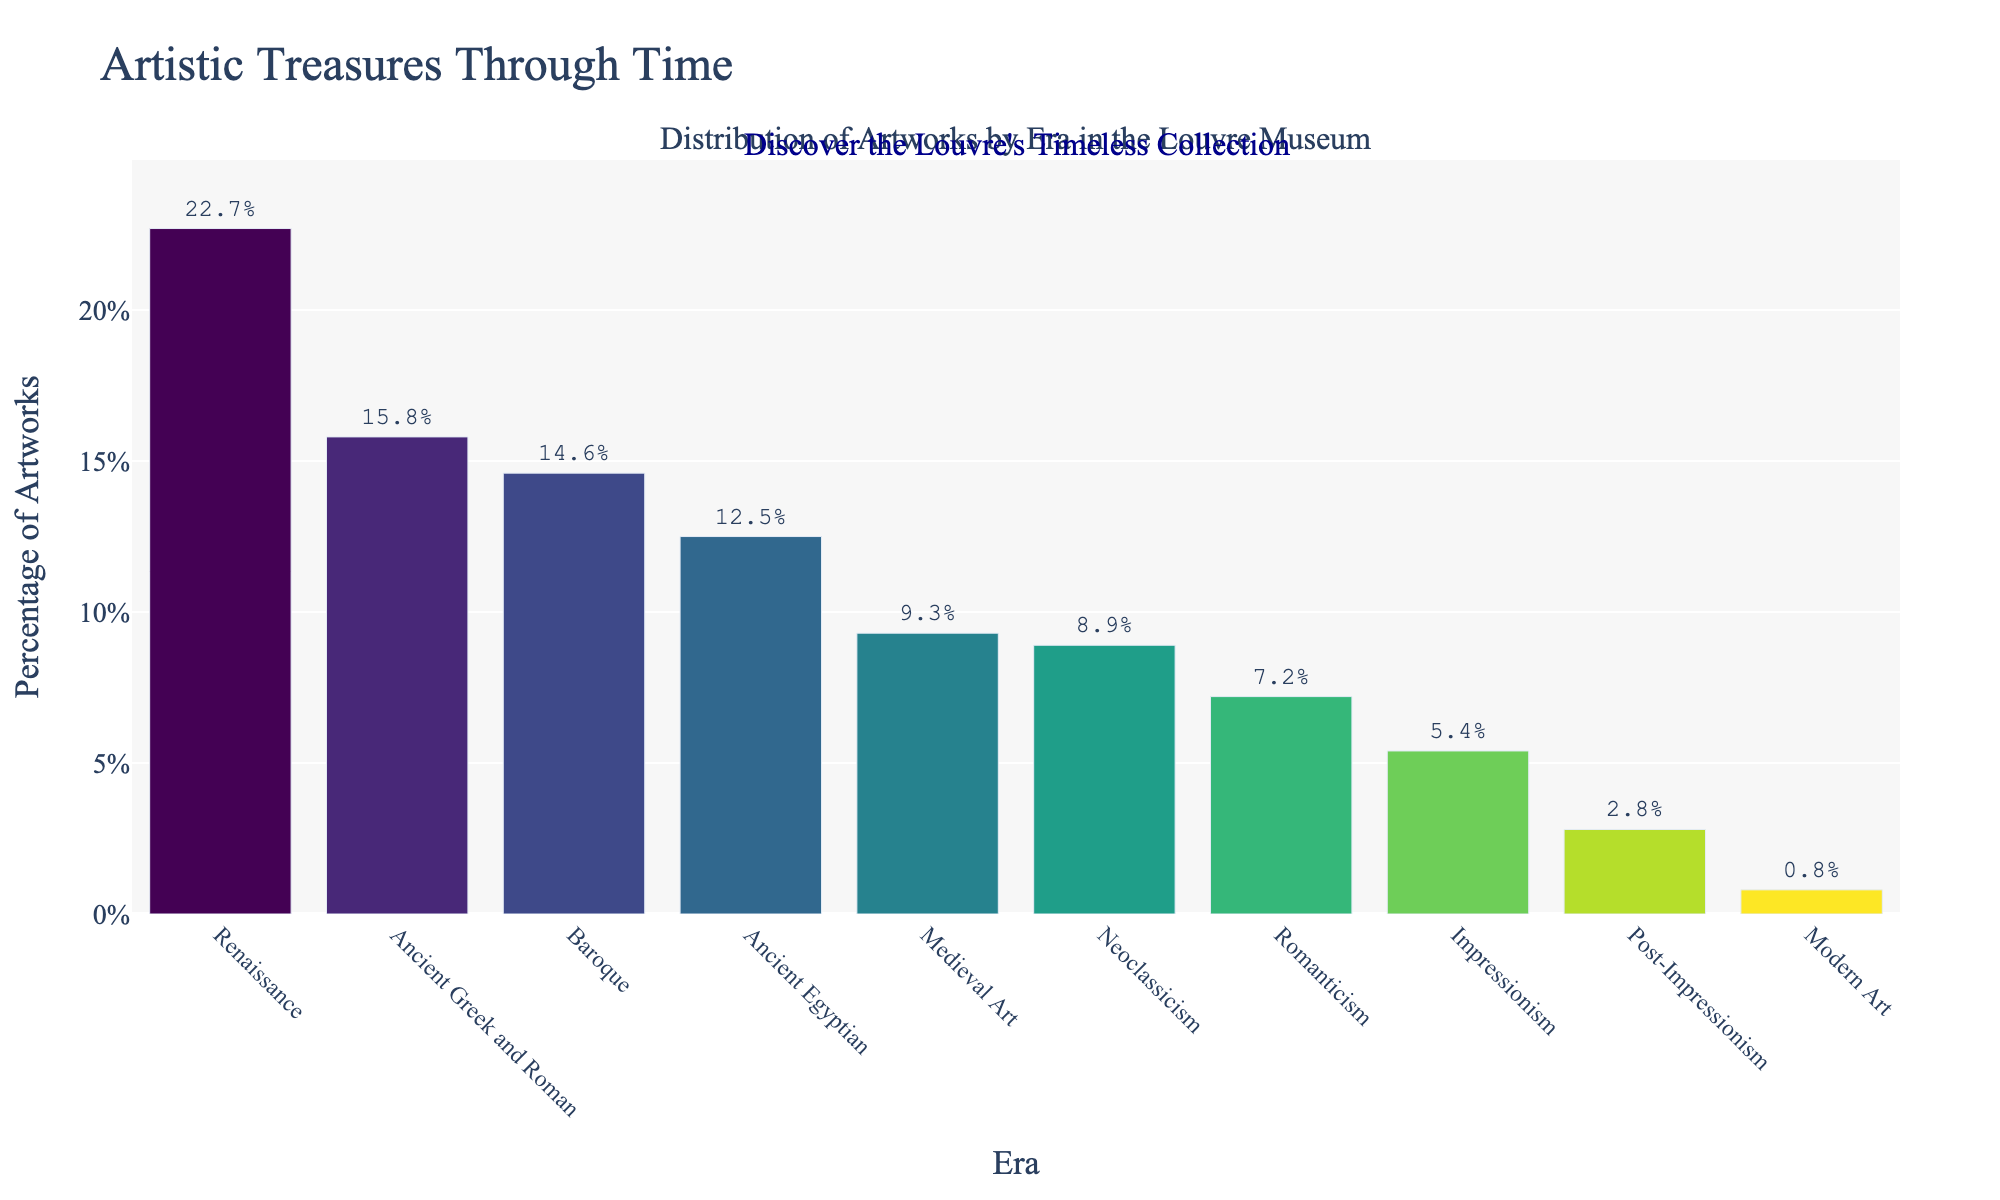What era comprises the highest percentage of artworks in the Louvre Museum? The bar for the Renaissance era is the tallest and reaches the value of 22.7%, indicating it has the highest percentage.
Answer: Renaissance Which two eras together account for more than 30% of the art collection in the Louvre? The Renaissance era is 22.7% and the Ancient Greek and Roman era is 15.8%. Summing these gives 22.7% + 15.8% = 38.5%, which is greater than 30%.
Answer: Renaissance, Ancient Greek and Roman What is the percentage difference between Baroque and Medieval Art eras? The Baroque era is 14.6% and the Medieval Art era is 9.3%. Subtracting these gives 14.6% - 9.3% = 5.3%.
Answer: 5.3% Which era has a greater percentage of artworks, Impressionism or Romanticism? The bars for Romanticism and Impressionism show 7.2% and 5.4% respectively, indicating Romanticism has a greater percentage.
Answer: Romanticism Rank the top three eras in terms of artwork percentage in descending order. The three tallest bars representing the highest percentages are: Renaissance (22.7%), Ancient Greek and Roman (15.8%), and Baroque (14.6%).
Answer: Renaissance, Ancient Greek and Roman, Baroque How many eras have a percentage of artworks less than 10%? The eras with percentages less than 10% are Medieval Art (9.3%), Neoclassicism (8.9%), Romanticism (7.2%), Impressionism (5.4%), Post-Impressionism (2.8%), and Modern Art (0.8%). There are 6 such eras.
Answer: 6 What is the total percentage of artworks from Ancient Egyptian, Medieval Art, and Modern Art eras combined? Adding the percentages for Ancient Egyptian (12.5%), Medieval Art (9.3%), and Modern Art (0.8%) gives 12.5% + 9.3% + 0.8% = 22.6%.
Answer: 22.6% Compare the percentage of artworks from Neoclassicism to the percentage of artworks from Baroque era. Which is larger and by how much? The Neoclassicism era has 8.9% and the Baroque era has 14.6%. The difference is 14.6% - 8.9% = 5.7%, making Baroque larger.
Answer: Baroque, 5.7% Is the percentage of artworks in the Renaissance era more than double that of Romanticism? The Renaissance has 22.7% and Romanticism has 7.2%. Doubling Romanticism gives 7.2% * 2 = 14.4%. Since 22.7% > 14.4%, the Renaissance era is more than double that of Romanticism.
Answer: Yes Which visual attribute signifies the era with the lowest percentage of artworks? The shortest bar corresponds to the Modern Art era at 0.8%, indicating the lowest percentage of artworks.
Answer: Modern Art 